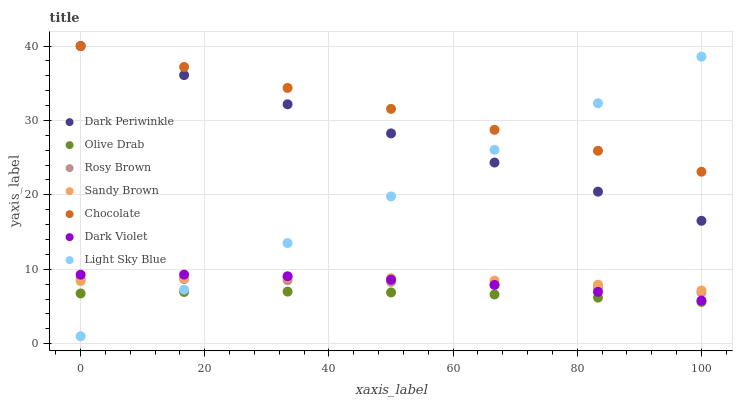Does Olive Drab have the minimum area under the curve?
Answer yes or no. Yes. Does Chocolate have the maximum area under the curve?
Answer yes or no. Yes. Does Dark Violet have the minimum area under the curve?
Answer yes or no. No. Does Dark Violet have the maximum area under the curve?
Answer yes or no. No. Is Light Sky Blue the smoothest?
Answer yes or no. Yes. Is Dark Violet the roughest?
Answer yes or no. Yes. Is Chocolate the smoothest?
Answer yes or no. No. Is Chocolate the roughest?
Answer yes or no. No. Does Light Sky Blue have the lowest value?
Answer yes or no. Yes. Does Dark Violet have the lowest value?
Answer yes or no. No. Does Dark Periwinkle have the highest value?
Answer yes or no. Yes. Does Dark Violet have the highest value?
Answer yes or no. No. Is Dark Violet less than Dark Periwinkle?
Answer yes or no. Yes. Is Chocolate greater than Sandy Brown?
Answer yes or no. Yes. Does Dark Violet intersect Rosy Brown?
Answer yes or no. Yes. Is Dark Violet less than Rosy Brown?
Answer yes or no. No. Is Dark Violet greater than Rosy Brown?
Answer yes or no. No. Does Dark Violet intersect Dark Periwinkle?
Answer yes or no. No. 